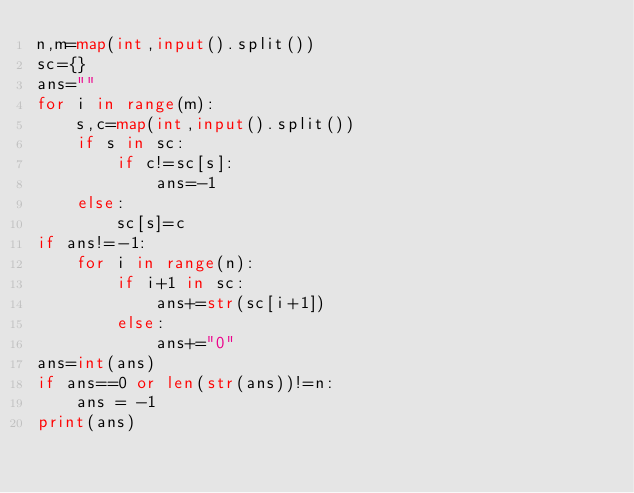Convert code to text. <code><loc_0><loc_0><loc_500><loc_500><_Python_>n,m=map(int,input().split())
sc={}
ans=""
for i in range(m):
    s,c=map(int,input().split())
    if s in sc:
        if c!=sc[s]:
            ans=-1
    else:
        sc[s]=c
if ans!=-1:
    for i in range(n):
        if i+1 in sc:
            ans+=str(sc[i+1])
        else:
            ans+="0"
ans=int(ans)
if ans==0 or len(str(ans))!=n:
    ans = -1
print(ans)</code> 